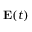Convert formula to latex. <formula><loc_0><loc_0><loc_500><loc_500>E ( t )</formula> 